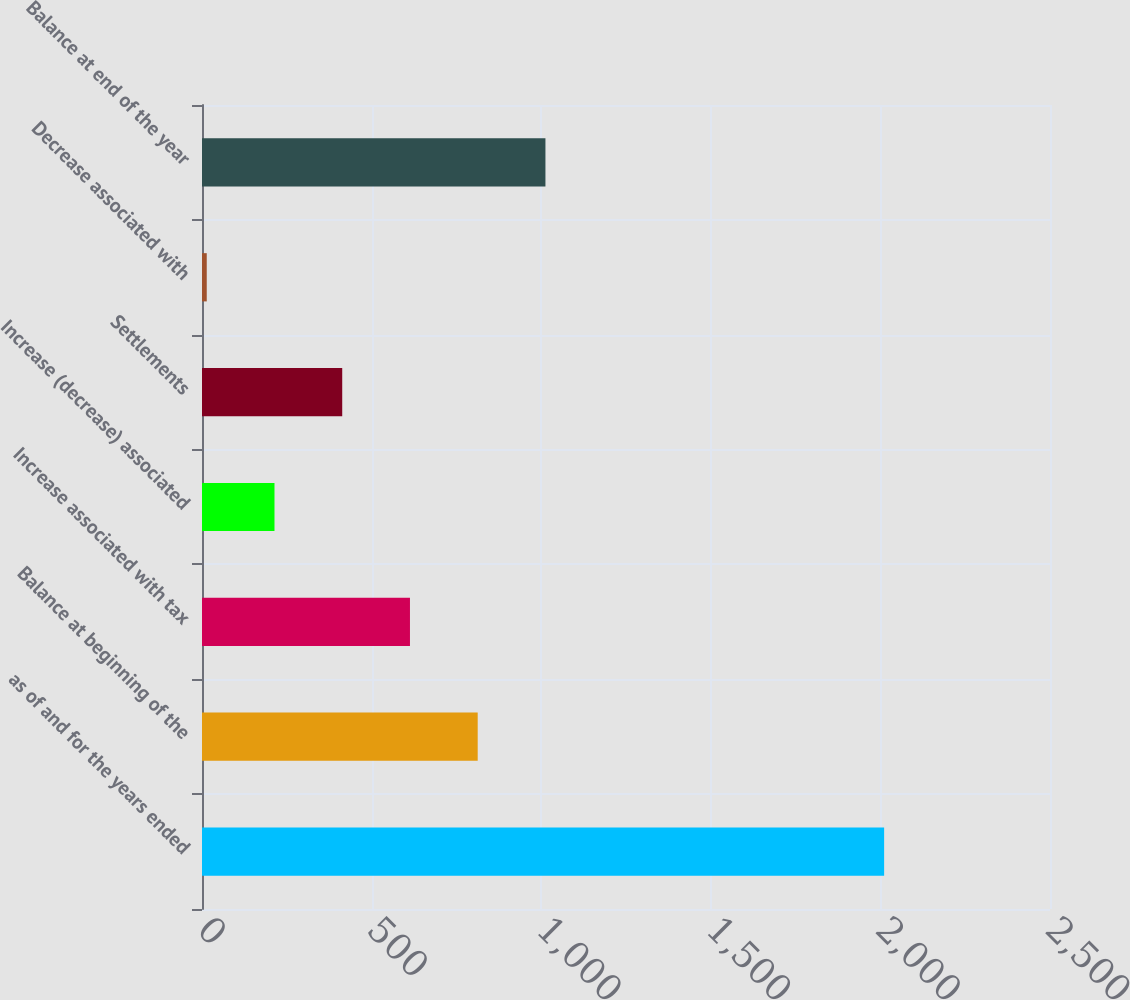<chart> <loc_0><loc_0><loc_500><loc_500><bar_chart><fcel>as of and for the years ended<fcel>Balance at beginning of the<fcel>Increase associated with tax<fcel>Increase (decrease) associated<fcel>Settlements<fcel>Decrease associated with<fcel>Balance at end of the year<nl><fcel>2011<fcel>812.8<fcel>613.1<fcel>213.7<fcel>413.4<fcel>14<fcel>1012.5<nl></chart> 